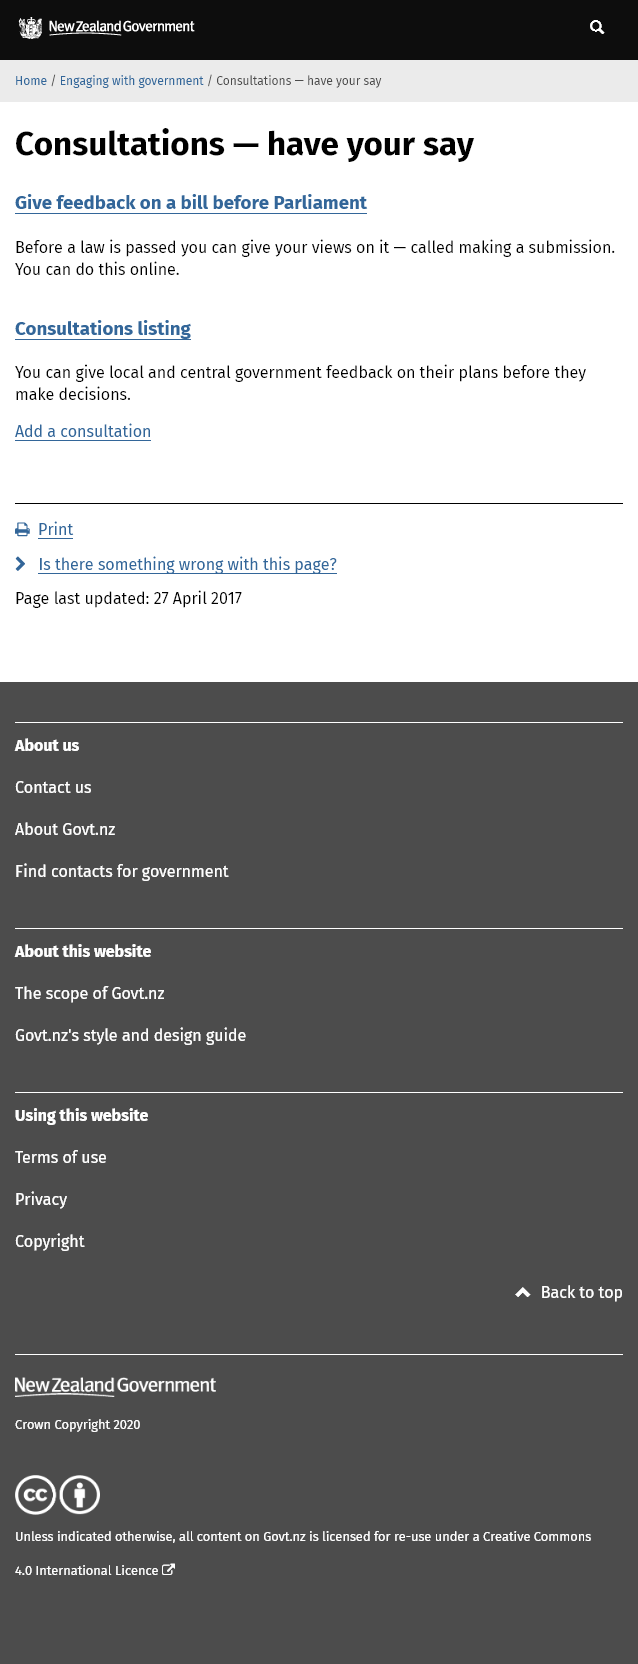Mention a couple of crucial points in this snapshot. It is possible to provide feedback at the Parliament, Central, and Local government levels. Yes, members of the public can have a say on Parliamentary bills by submitting their views online before a law is passed. 